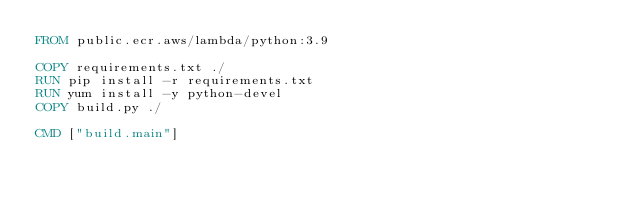Convert code to text. <code><loc_0><loc_0><loc_500><loc_500><_Dockerfile_>FROM public.ecr.aws/lambda/python:3.9

COPY requirements.txt ./
RUN pip install -r requirements.txt
RUN yum install -y python-devel
COPY build.py ./

CMD ["build.main"]</code> 